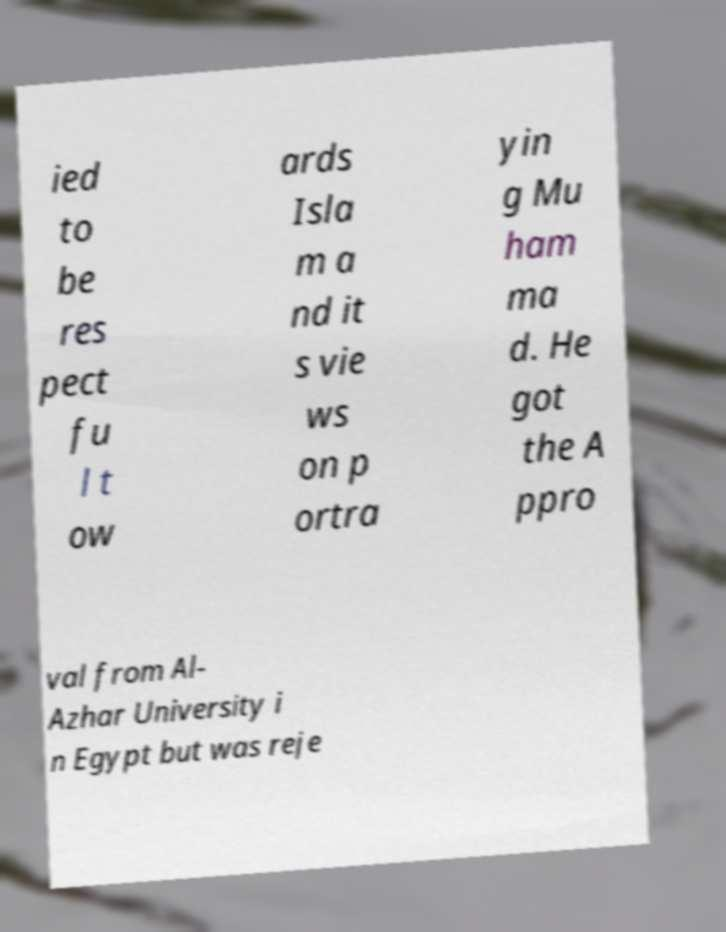Please read and relay the text visible in this image. What does it say? ied to be res pect fu l t ow ards Isla m a nd it s vie ws on p ortra yin g Mu ham ma d. He got the A ppro val from Al- Azhar University i n Egypt but was reje 